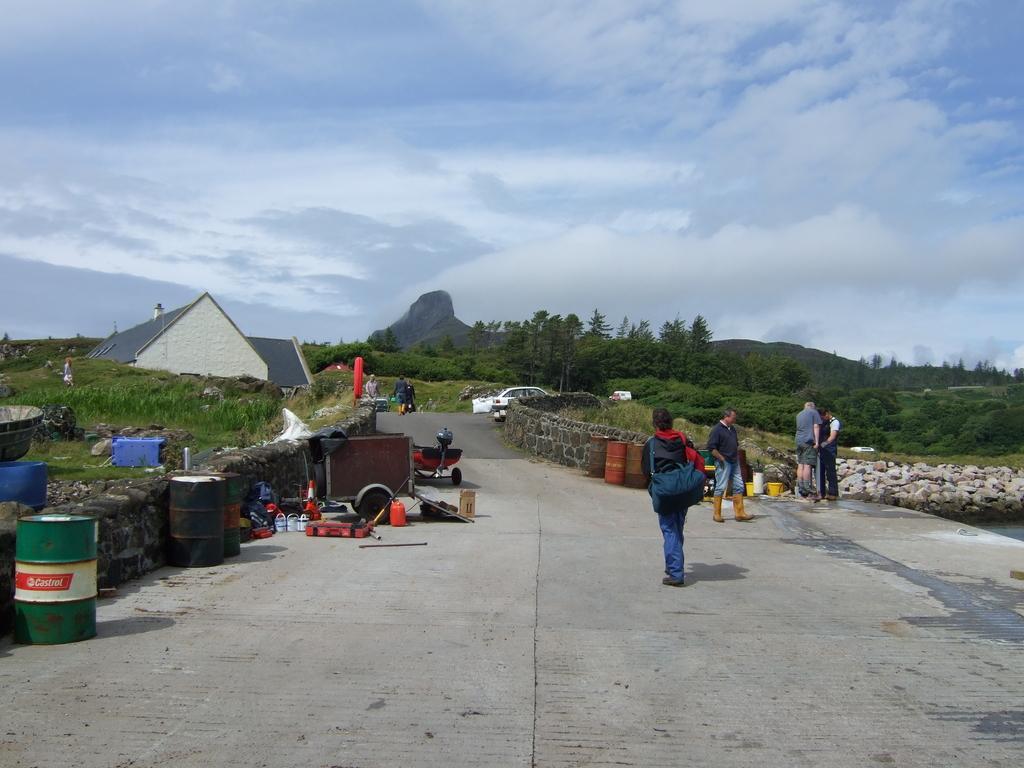Could you give a brief overview of what you see in this image? In this picture, we can see a few people, the road and some objects on the road, we can see the house, plants, trees, stone and the sky with clouds. 